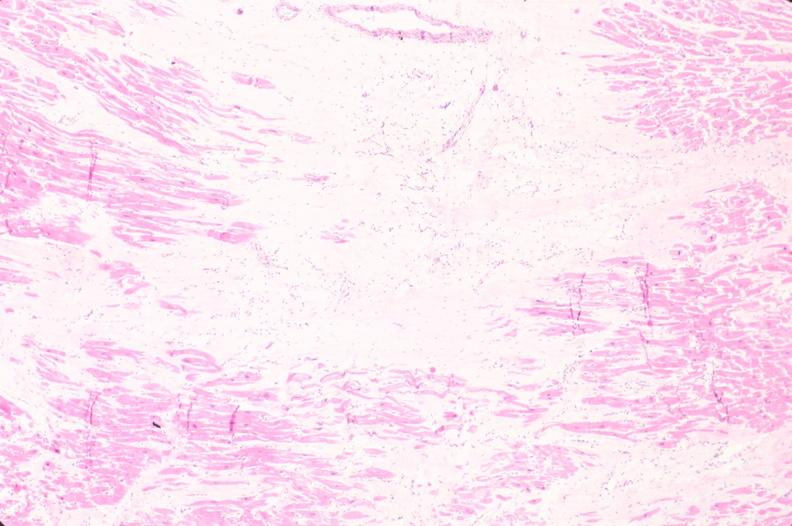where is this in?
Answer the question using a single word or phrase. In heart 